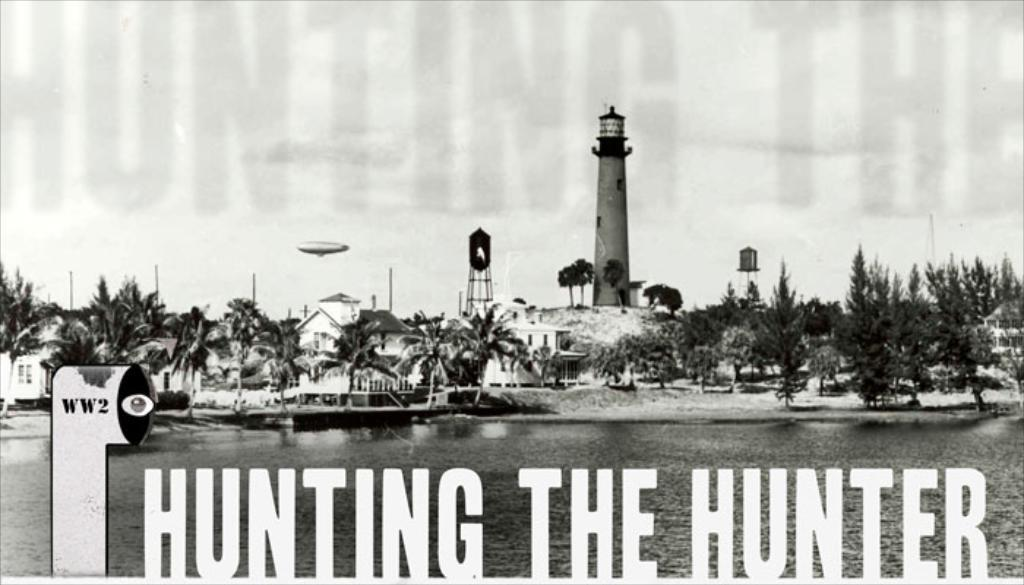What is the main subject of the image? The main subject of the image is a boat. Where is the boat located? The boat is on water. What can be seen in the background of the image? There are buildings, towers, trees, and the sky visible in the background of the image. Is there any text present in the image? Yes, there is text at the bottom of the image. How many turkeys are visible in the image? There are no turkeys present in the image. What type of animal can be seen interacting with the boat in the image? There are no animals visible in the image; only the boat, water, and background elements are present. 